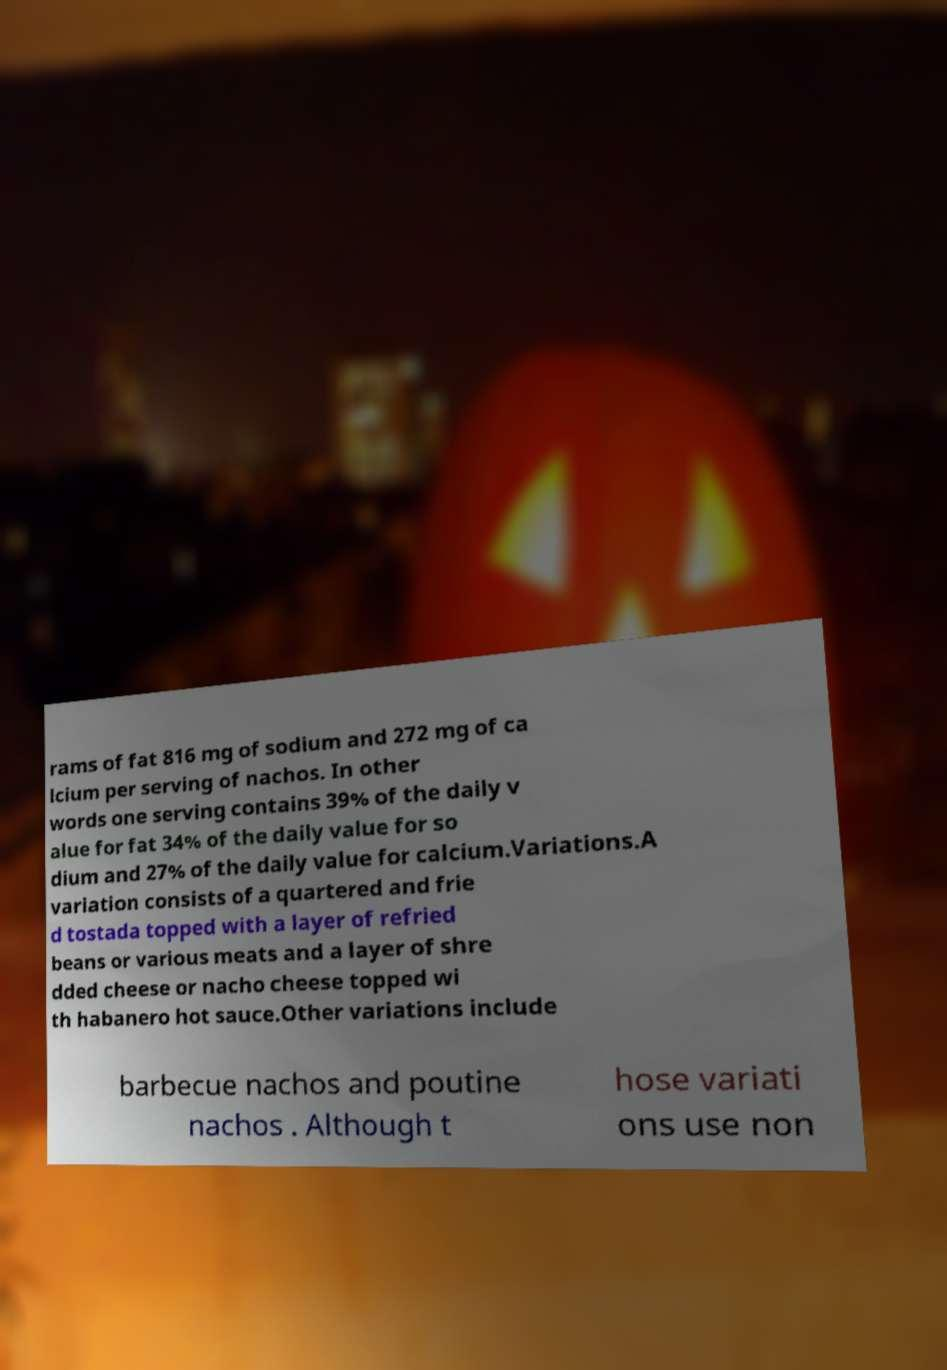What messages or text are displayed in this image? I need them in a readable, typed format. rams of fat 816 mg of sodium and 272 mg of ca lcium per serving of nachos. In other words one serving contains 39% of the daily v alue for fat 34% of the daily value for so dium and 27% of the daily value for calcium.Variations.A variation consists of a quartered and frie d tostada topped with a layer of refried beans or various meats and a layer of shre dded cheese or nacho cheese topped wi th habanero hot sauce.Other variations include barbecue nachos and poutine nachos . Although t hose variati ons use non 